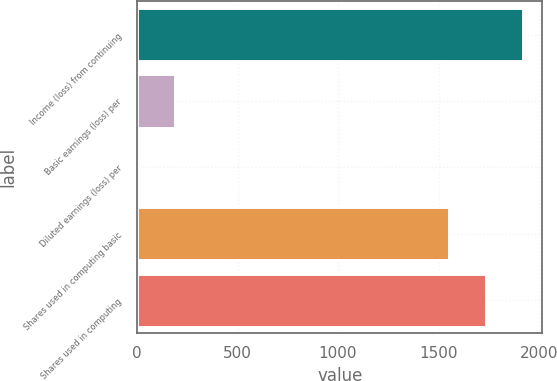Convert chart to OTSL. <chart><loc_0><loc_0><loc_500><loc_500><bar_chart><fcel>Income (loss) from continuing<fcel>Basic earnings (loss) per<fcel>Diluted earnings (loss) per<fcel>Shares used in computing basic<fcel>Shares used in computing<nl><fcel>1920.76<fcel>186.54<fcel>1.16<fcel>1550<fcel>1735.38<nl></chart> 